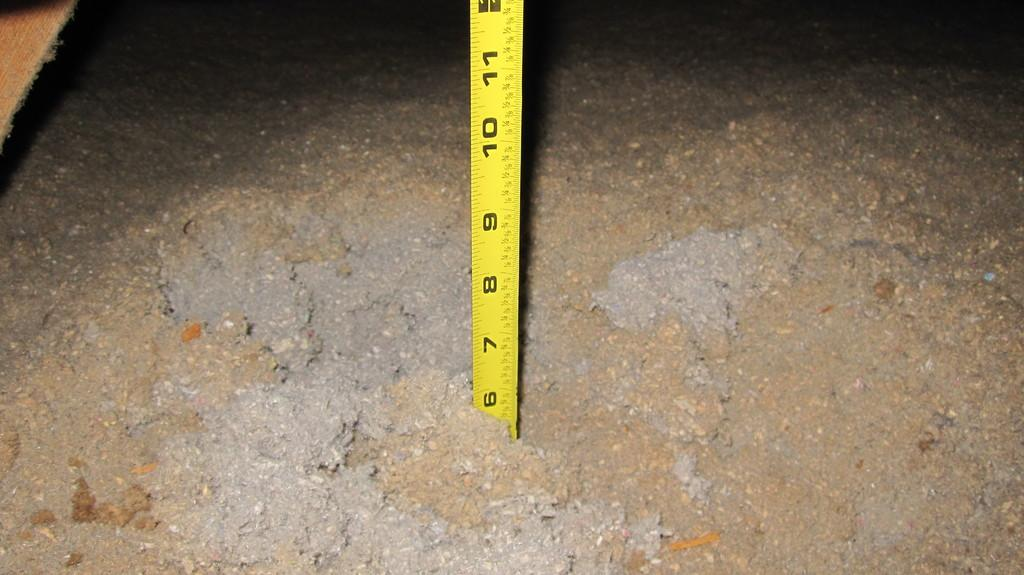What is at the bottom of the image? There is mud at the bottom of the image. What can be found in the middle of the mud? There is a tap in the middle of the mud. What color is the tap? The tap has a yellow color. What feature is present on the tap? There are measurements on the tap. Can you see a bird sitting on the tap in the image? There is no bird present in the image; it only features mud, a yellow tap, and measurements on the tap. What type of spot does the tap have on it? The tap does not have a spot; it has a yellow color. 